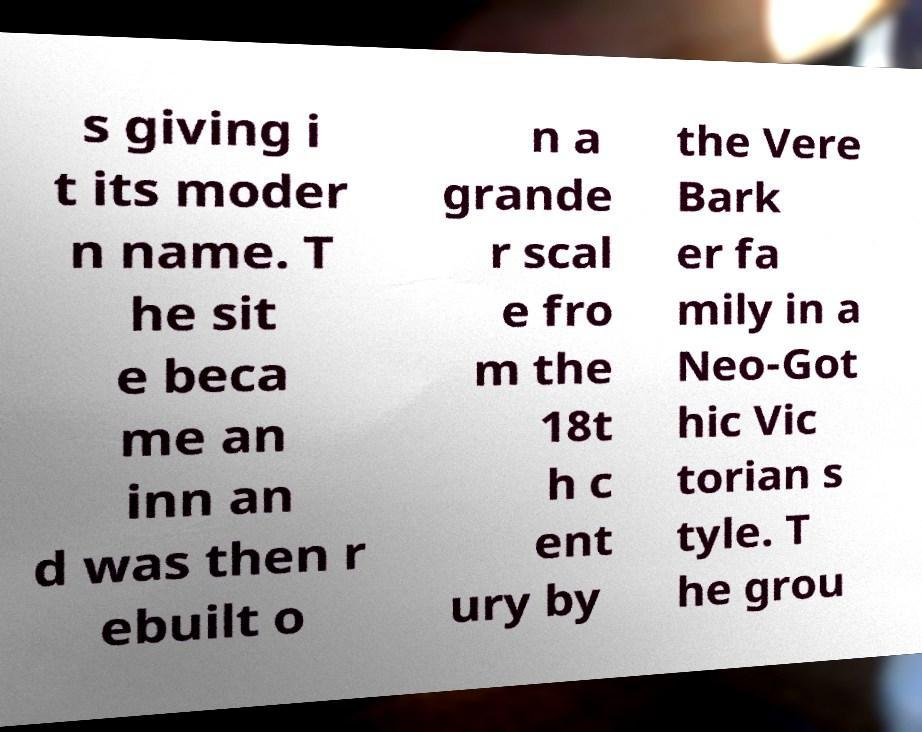There's text embedded in this image that I need extracted. Can you transcribe it verbatim? s giving i t its moder n name. T he sit e beca me an inn an d was then r ebuilt o n a grande r scal e fro m the 18t h c ent ury by the Vere Bark er fa mily in a Neo-Got hic Vic torian s tyle. T he grou 